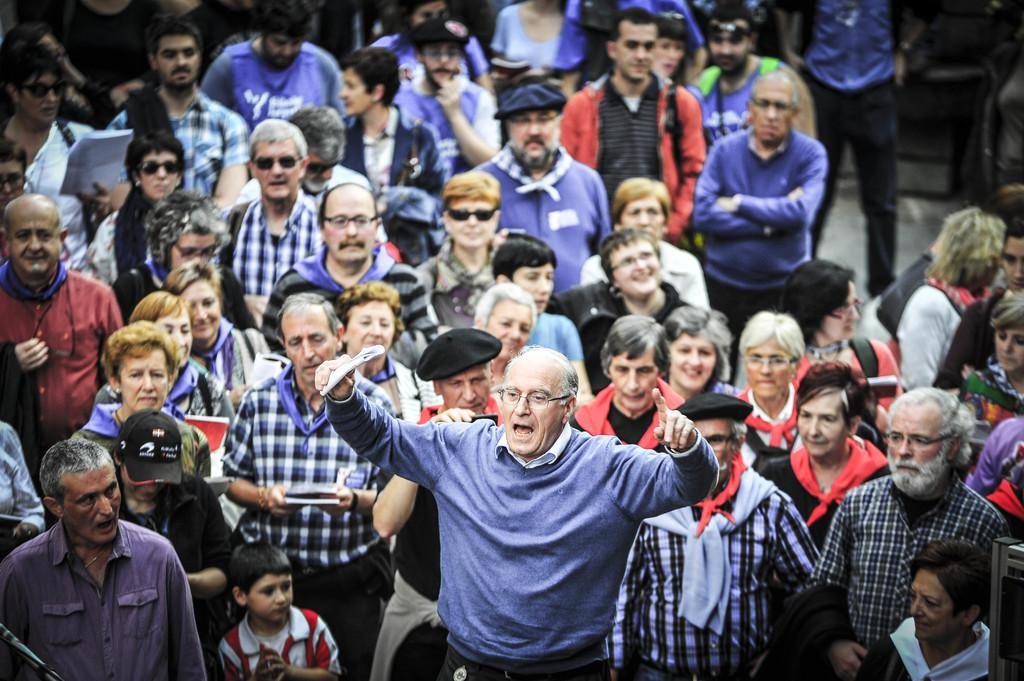How many people are in the image? There are people in the image, but the exact number is not specified. What are the people in the image doing? The people are standing on a path. Can you describe the position of the man in the front of the group? The man in the front of the group is holding something in his hand. What type of breakfast is the man in the front of the group eating in the image? There is no indication of breakfast or any food in the image; the man is holding something in his hand, but it is not specified what it is. 